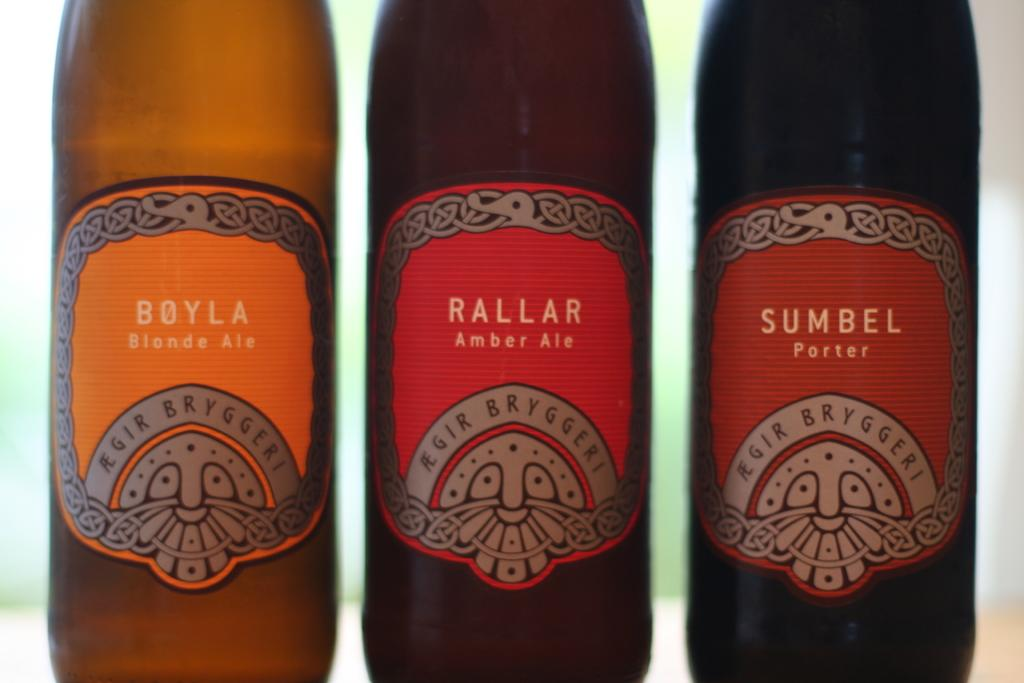<image>
Summarize the visual content of the image. Three bottles of different types of beer are shown, one of which is a Porter. 